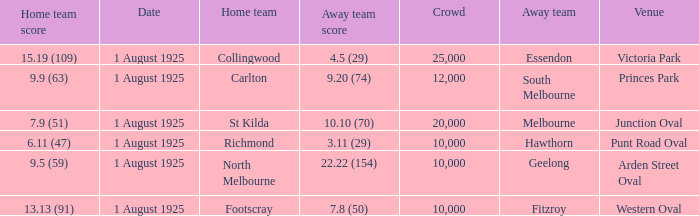Which team has their home games at princes park? Carlton. 